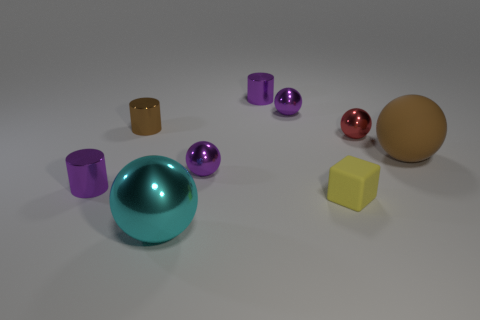Is the rubber sphere the same color as the small block?
Your response must be concise. No. How many things have the same color as the large matte ball?
Your answer should be very brief. 1. What is the size of the purple cylinder behind the purple metallic ball behind the red ball?
Offer a terse response. Small. What shape is the small red thing?
Offer a very short reply. Sphere. There is a small object on the right side of the yellow matte thing; what material is it?
Keep it short and to the point. Metal. The matte object that is in front of the small cylinder in front of the big ball behind the cyan metallic ball is what color?
Give a very brief answer. Yellow. The other shiny sphere that is the same size as the brown ball is what color?
Ensure brevity in your answer.  Cyan. How many metallic objects are either red blocks or blocks?
Offer a very short reply. 0. There is a large thing that is the same material as the tiny red object; what color is it?
Offer a very short reply. Cyan. There is a big thing that is to the right of the big sphere left of the yellow rubber block; what is it made of?
Your answer should be compact. Rubber. 